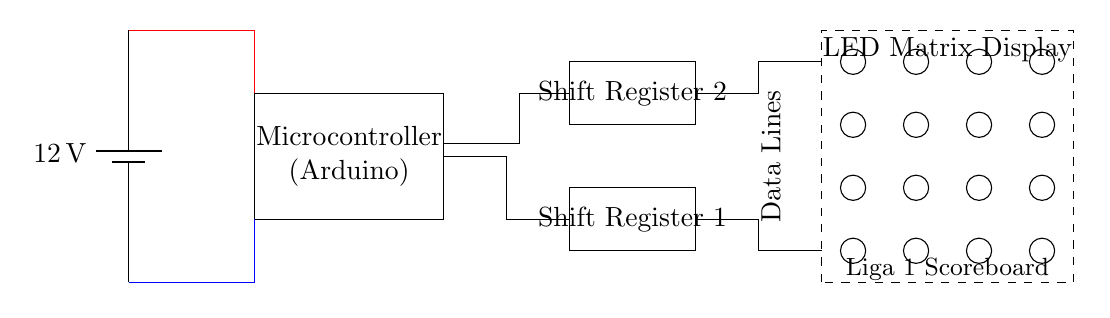What is the voltage of the power supply? The circuit shows a battery labeled as 12V at the power supply section. This indicates that the voltage of the power supply providing energy to the components is 12 volts.
Answer: 12 volts What type of microcontroller is used? In the diagram, there is a rectangular shape labeled "Microcontroller (Arduino)". This indicates that the type of microcontroller utilized in the circuit is an Arduino.
Answer: Arduino How many shift registers are present? The diagram displays two rectangular components labeled "Shift Register 1" and "Shift Register 2". This indicates that there are two shift registers included in the circuit design.
Answer: Two What is the function of the LED matrix display? The circuit represents the LED matrix display as a dashed rectangle labeled "LED Matrix Display". This implies that the function of the LED matrix display is to visually represent data output from the microcontroller, typically for scoreboard purposes.
Answer: Data output display What connections do the microcontroller have with the shift registers? The diagram shows direct connections between the microcontroller and both shift registers via lines. These connections indicate that the microcontroller sends data lines to the shift registers for controlling the LED display.
Answer: Data lines What is the significance of the color-coded lines? The power connections are shown in red (for positive voltage from the battery) and blue (for ground connections). This color-coding helps quickly identify the positive and negative connections, which is crucial for correct circuit operation.
Answer: Positive and ground identification What does the dashed rectangle represent? The dashed rectangle labeled "LED Matrix Display" visually indicates that this component is potentially modular or a significant area of focus; commonly, it represents the area dedicated to displaying score data on the scoreboard.
Answer: LED matrix component 